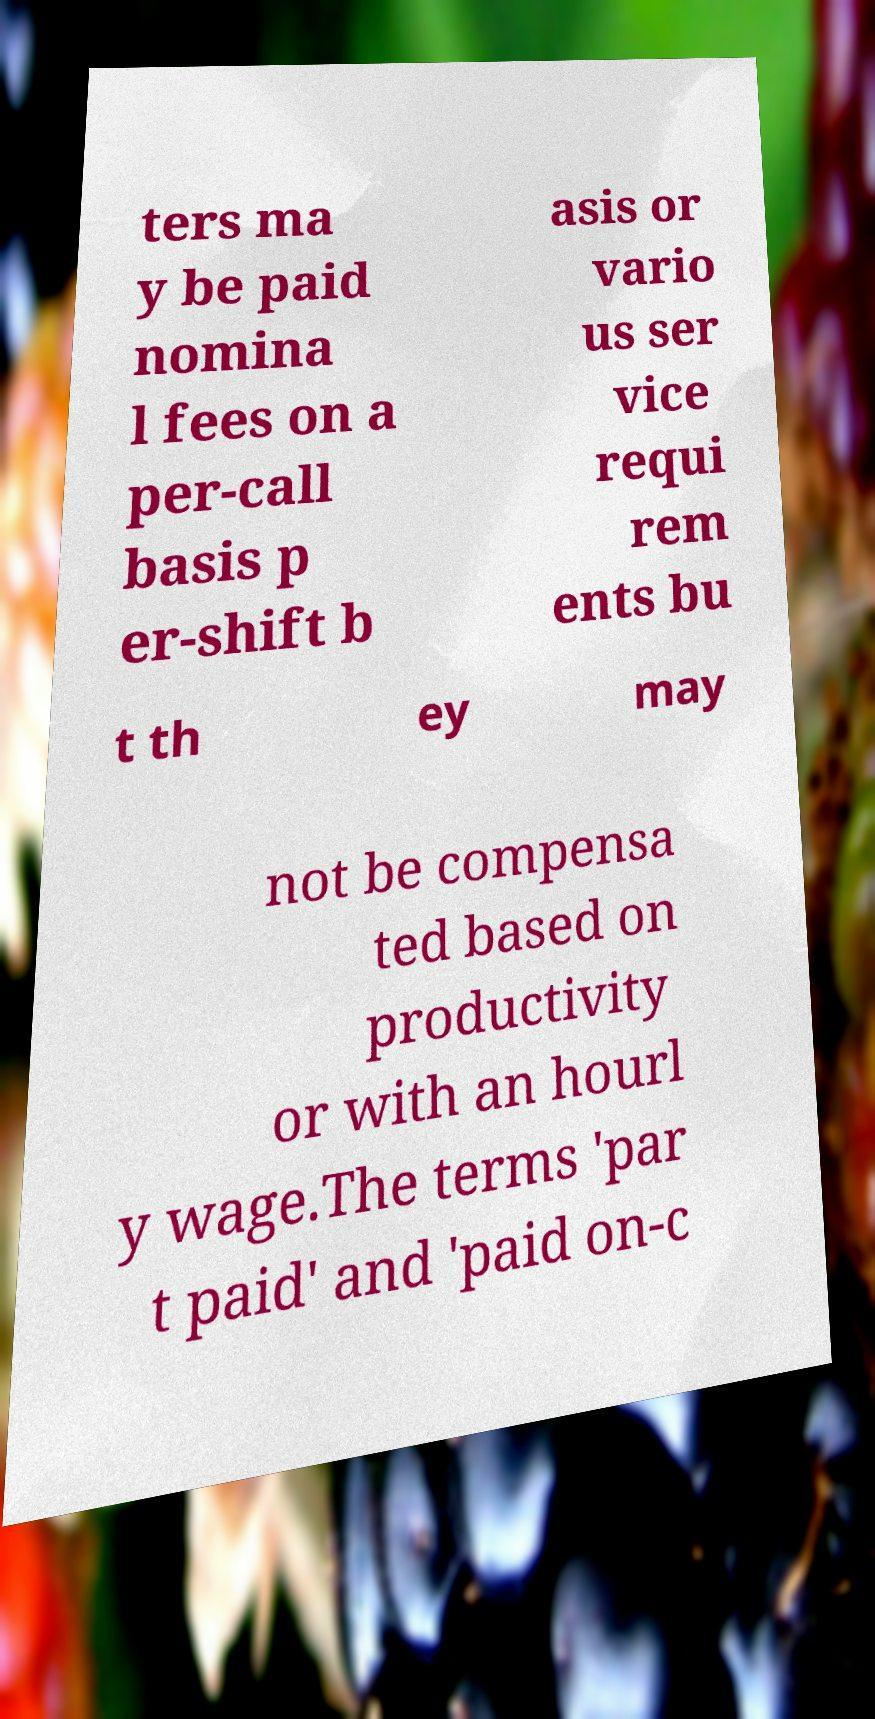Please read and relay the text visible in this image. What does it say? ters ma y be paid nomina l fees on a per-call basis p er-shift b asis or vario us ser vice requi rem ents bu t th ey may not be compensa ted based on productivity or with an hourl y wage.The terms 'par t paid' and 'paid on-c 